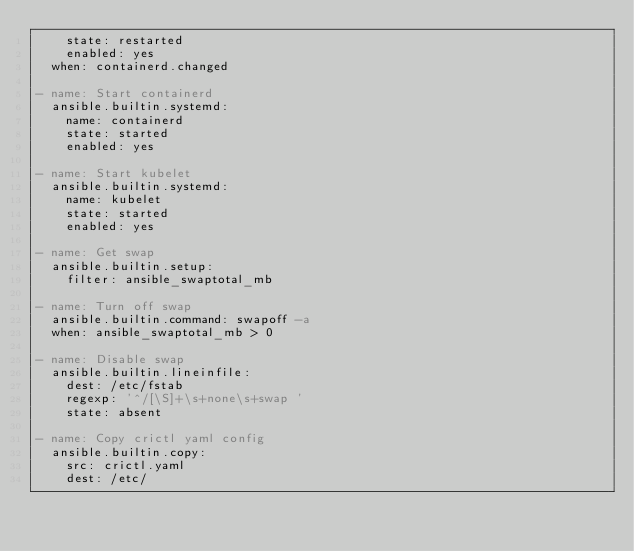<code> <loc_0><loc_0><loc_500><loc_500><_YAML_>    state: restarted
    enabled: yes
  when: containerd.changed

- name: Start containerd
  ansible.builtin.systemd:
    name: containerd
    state: started
    enabled: yes

- name: Start kubelet
  ansible.builtin.systemd:
    name: kubelet
    state: started
    enabled: yes

- name: Get swap
  ansible.builtin.setup:
    filter: ansible_swaptotal_mb

- name: Turn off swap
  ansible.builtin.command: swapoff -a
  when: ansible_swaptotal_mb > 0

- name: Disable swap
  ansible.builtin.lineinfile:
    dest: /etc/fstab
    regexp: '^/[\S]+\s+none\s+swap '
    state: absent

- name: Copy crictl yaml config
  ansible.builtin.copy:
    src: crictl.yaml
    dest: /etc/
</code> 